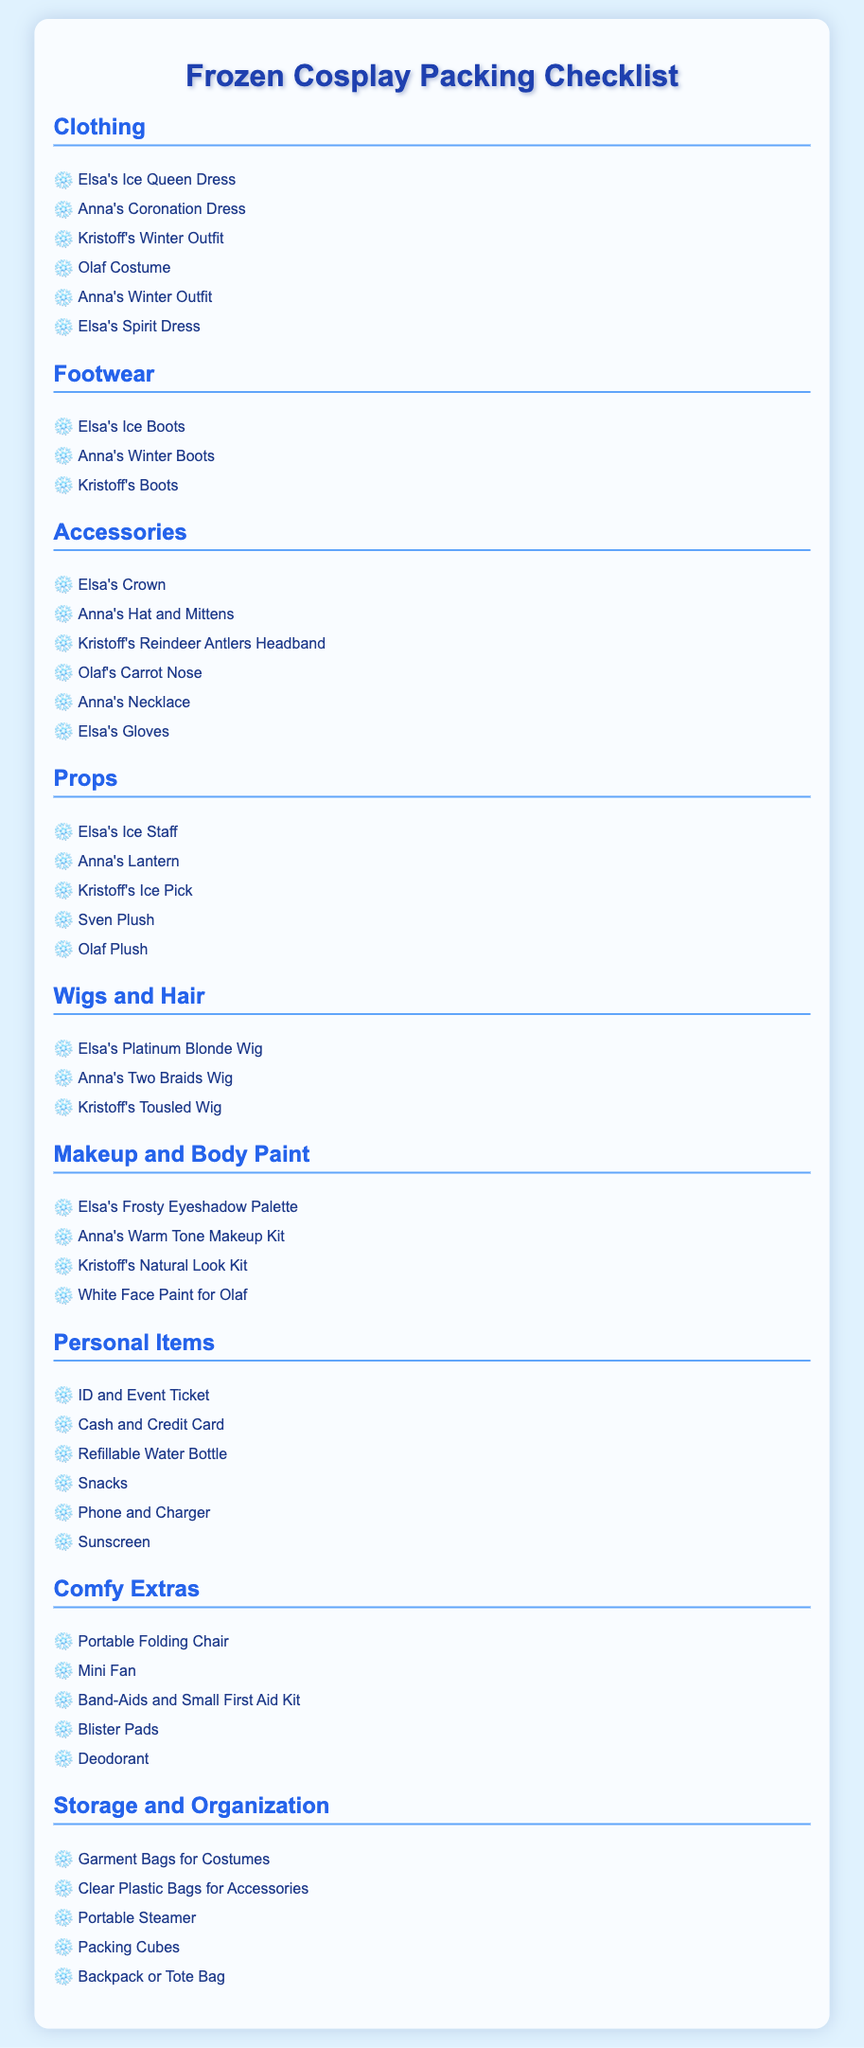What costumes are listed under Clothing? The Clothing category includes specific costumes like Elsa's Ice Queen Dress and others mentioned in the list.
Answer: Elsa's Ice Queen Dress, Anna's Coronation Dress, Kristoff's Winter Outfit, Olaf Costume, Anna's Winter Outfit, Elsa's Spirit Dress How many accessories are there? The Accessories category lists multiple items, and by counting them, we find the total number.
Answer: 6 What footwear does Kristoff wear? The Footwear category includes Kristoff's boots as listed.
Answer: Kristoff's Boots What is included in the Personal Items category? The Personal Items category contains crucial items that a cosplayer would need at an event, such as ID and tickets.
Answer: ID and Event Ticket, Cash and Credit Card, Refillable Water Bottle, Snacks, Phone and Charger, Sunscreen Which character has a frosty eyeshadow palette? Elsa's makeup item listed is specifically a Frosty Eyeshadow Palette.
Answer: Elsa's Frosty Eyeshadow Palette What type of chair is suggested as a comfy extra? The Comfy Extras category suggests a portable chair for comfort during the event.
Answer: Portable Folding Chair Which costume should Olaf wear? The Props category includes an Olaf plush, emphasizing Olaf's costume requirement.
Answer: Olaf Costume How many wigs are mentioned in the Wigs and Hair section? The Wigs and Hair category lists different wigs, and we can count them for the total.
Answer: 3 